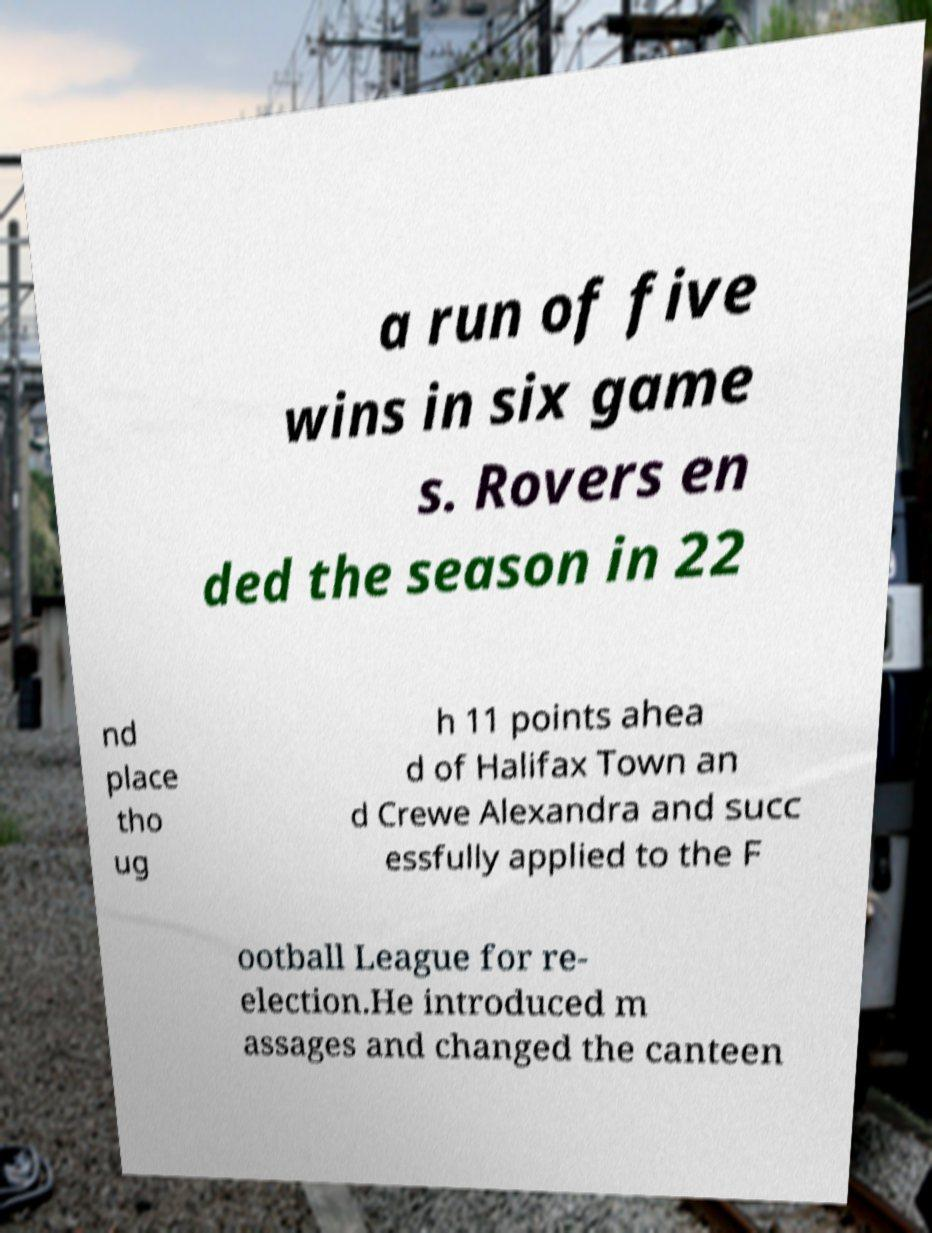Could you extract and type out the text from this image? a run of five wins in six game s. Rovers en ded the season in 22 nd place tho ug h 11 points ahea d of Halifax Town an d Crewe Alexandra and succ essfully applied to the F ootball League for re- election.He introduced m assages and changed the canteen 